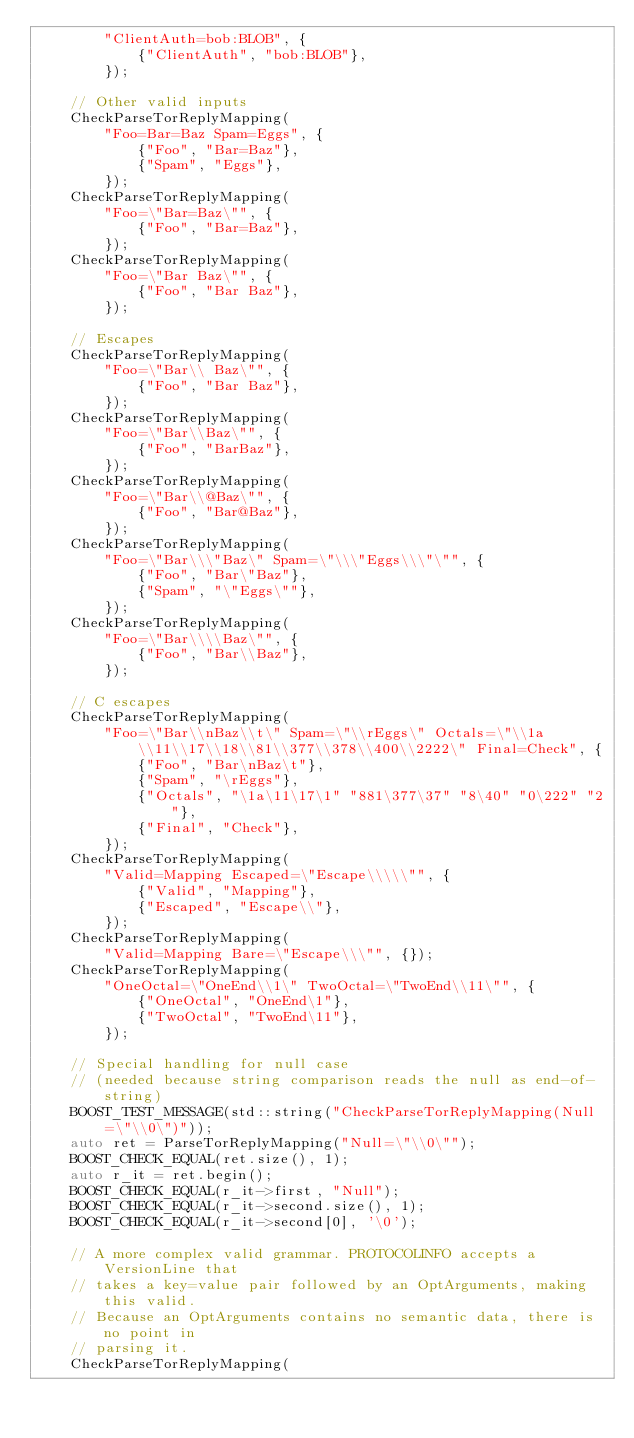Convert code to text. <code><loc_0><loc_0><loc_500><loc_500><_C++_>        "ClientAuth=bob:BLOB", {
            {"ClientAuth", "bob:BLOB"},
        });

    // Other valid inputs
    CheckParseTorReplyMapping(
        "Foo=Bar=Baz Spam=Eggs", {
            {"Foo", "Bar=Baz"},
            {"Spam", "Eggs"},
        });
    CheckParseTorReplyMapping(
        "Foo=\"Bar=Baz\"", {
            {"Foo", "Bar=Baz"},
        });
    CheckParseTorReplyMapping(
        "Foo=\"Bar Baz\"", {
            {"Foo", "Bar Baz"},
        });

    // Escapes
    CheckParseTorReplyMapping(
        "Foo=\"Bar\\ Baz\"", {
            {"Foo", "Bar Baz"},
        });
    CheckParseTorReplyMapping(
        "Foo=\"Bar\\Baz\"", {
            {"Foo", "BarBaz"},
        });
    CheckParseTorReplyMapping(
        "Foo=\"Bar\\@Baz\"", {
            {"Foo", "Bar@Baz"},
        });
    CheckParseTorReplyMapping(
        "Foo=\"Bar\\\"Baz\" Spam=\"\\\"Eggs\\\"\"", {
            {"Foo", "Bar\"Baz"},
            {"Spam", "\"Eggs\""},
        });
    CheckParseTorReplyMapping(
        "Foo=\"Bar\\\\Baz\"", {
            {"Foo", "Bar\\Baz"},
        });

    // C escapes
    CheckParseTorReplyMapping(
        "Foo=\"Bar\\nBaz\\t\" Spam=\"\\rEggs\" Octals=\"\\1a\\11\\17\\18\\81\\377\\378\\400\\2222\" Final=Check", {
            {"Foo", "Bar\nBaz\t"},
            {"Spam", "\rEggs"},
            {"Octals", "\1a\11\17\1" "881\377\37" "8\40" "0\222" "2"},
            {"Final", "Check"},
        });
    CheckParseTorReplyMapping(
        "Valid=Mapping Escaped=\"Escape\\\\\"", {
            {"Valid", "Mapping"},
            {"Escaped", "Escape\\"},
        });
    CheckParseTorReplyMapping(
        "Valid=Mapping Bare=\"Escape\\\"", {});
    CheckParseTorReplyMapping(
        "OneOctal=\"OneEnd\\1\" TwoOctal=\"TwoEnd\\11\"", {
            {"OneOctal", "OneEnd\1"},
            {"TwoOctal", "TwoEnd\11"},
        });

    // Special handling for null case
    // (needed because string comparison reads the null as end-of-string)
    BOOST_TEST_MESSAGE(std::string("CheckParseTorReplyMapping(Null=\"\\0\")"));
    auto ret = ParseTorReplyMapping("Null=\"\\0\"");
    BOOST_CHECK_EQUAL(ret.size(), 1);
    auto r_it = ret.begin();
    BOOST_CHECK_EQUAL(r_it->first, "Null");
    BOOST_CHECK_EQUAL(r_it->second.size(), 1);
    BOOST_CHECK_EQUAL(r_it->second[0], '\0');

    // A more complex valid grammar. PROTOCOLINFO accepts a VersionLine that
    // takes a key=value pair followed by an OptArguments, making this valid.
    // Because an OptArguments contains no semantic data, there is no point in
    // parsing it.
    CheckParseTorReplyMapping(</code> 